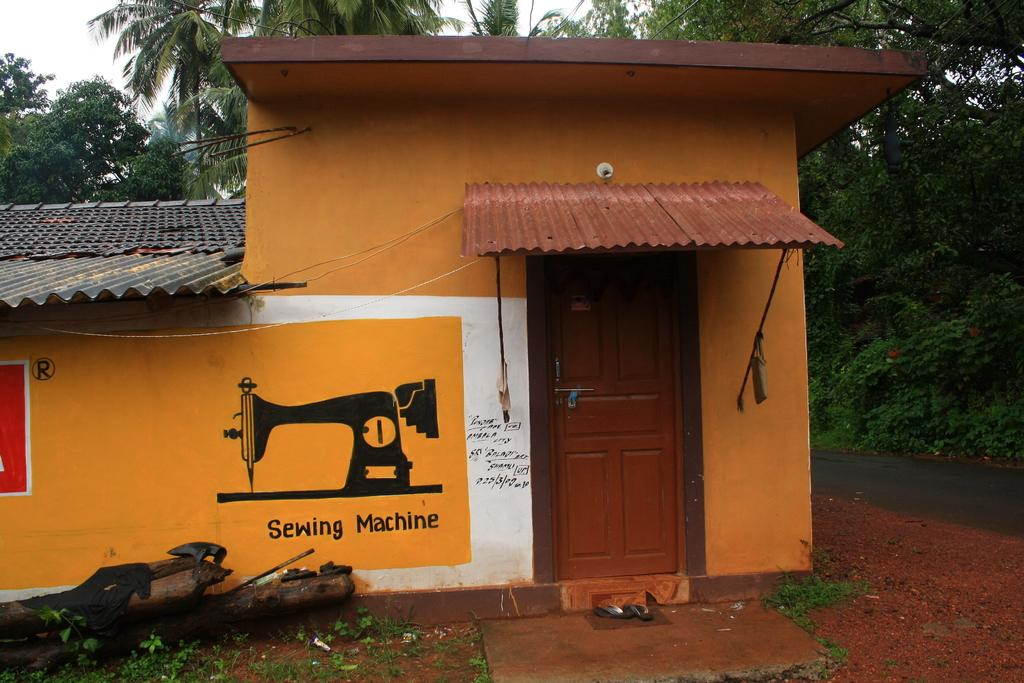What type of structure is visible in the image? There is a house in the image. What is the condition of the door on the house? The house has a closed wooden door. What can be seen in front of the house? There are objects in front of the house. What is located beside the house? There is a road beside the house. What is visible behind the house? There are trees behind the house. How many beams are supporting the roof of the house in the image? There is no information about beams supporting the roof of the house in the image. What type of sticks are being used to create a fence around the house? There is no fence made of sticks visible in the image. 